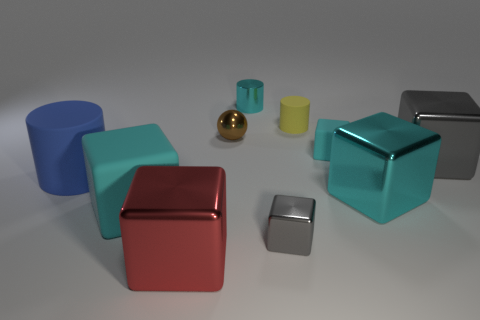Are there any other spheres that have the same color as the ball?
Provide a succinct answer. No. What is the size of the cyan rubber block behind the big metal cube to the right of the large cyan thing right of the tiny metallic block?
Offer a terse response. Small. Is the shape of the tiny brown metallic thing the same as the cyan shiny thing that is on the right side of the metallic cylinder?
Keep it short and to the point. No. What number of other things are there of the same size as the yellow cylinder?
Offer a terse response. 4. How big is the cyan metallic thing behind the big blue cylinder?
Ensure brevity in your answer.  Small. How many tiny gray things have the same material as the big red block?
Offer a terse response. 1. Does the tiny cyan object that is to the left of the tiny gray cube have the same shape as the large cyan rubber object?
Ensure brevity in your answer.  No. There is a cyan metal thing that is left of the small cyan matte object; what shape is it?
Ensure brevity in your answer.  Cylinder. The metallic block that is the same color as the large matte cube is what size?
Your answer should be compact. Large. What material is the tiny sphere?
Your answer should be compact. Metal. 